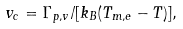<formula> <loc_0><loc_0><loc_500><loc_500>v _ { c } = \Gamma _ { p , v } / [ k _ { B } ( T _ { m , e } - T ) ] ,</formula> 